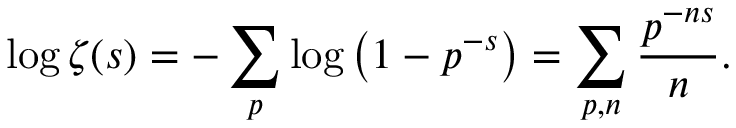Convert formula to latex. <formula><loc_0><loc_0><loc_500><loc_500>\log \zeta ( s ) = - \sum _ { p } \log \left ( 1 - p ^ { - s } \right ) = \sum _ { p , n } { \frac { p ^ { - n s } } { n } } .</formula> 